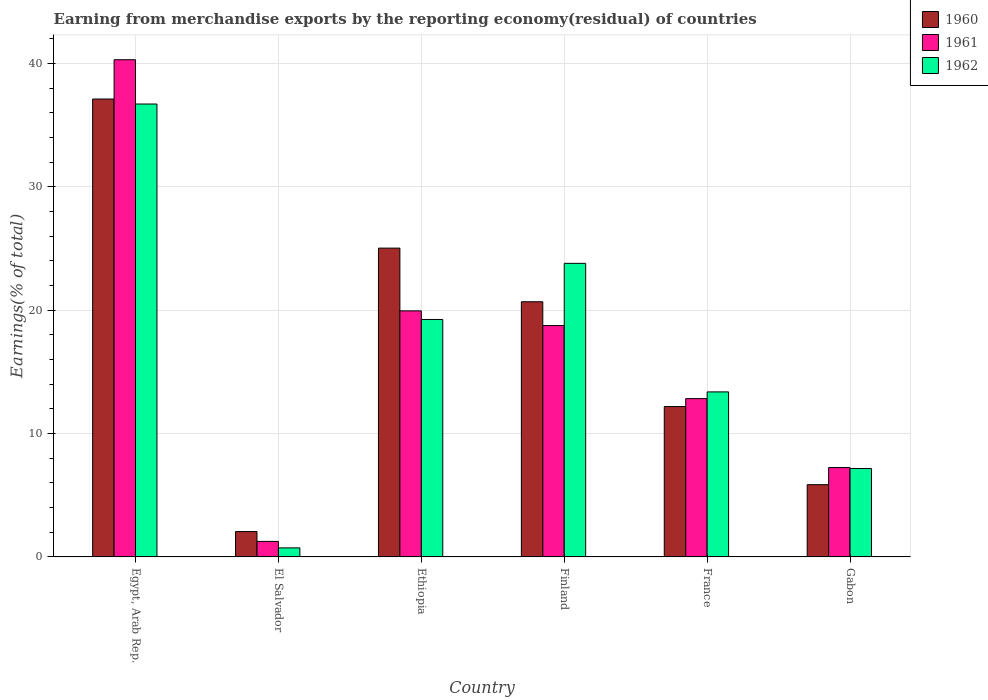How many different coloured bars are there?
Provide a short and direct response. 3. How many groups of bars are there?
Offer a terse response. 6. Are the number of bars per tick equal to the number of legend labels?
Provide a succinct answer. Yes. How many bars are there on the 5th tick from the left?
Provide a succinct answer. 3. How many bars are there on the 5th tick from the right?
Provide a short and direct response. 3. What is the label of the 3rd group of bars from the left?
Provide a succinct answer. Ethiopia. In how many cases, is the number of bars for a given country not equal to the number of legend labels?
Provide a succinct answer. 0. What is the percentage of amount earned from merchandise exports in 1960 in Ethiopia?
Provide a short and direct response. 25.03. Across all countries, what is the maximum percentage of amount earned from merchandise exports in 1960?
Your answer should be very brief. 37.12. Across all countries, what is the minimum percentage of amount earned from merchandise exports in 1962?
Your answer should be compact. 0.73. In which country was the percentage of amount earned from merchandise exports in 1962 maximum?
Give a very brief answer. Egypt, Arab Rep. In which country was the percentage of amount earned from merchandise exports in 1960 minimum?
Provide a short and direct response. El Salvador. What is the total percentage of amount earned from merchandise exports in 1962 in the graph?
Provide a short and direct response. 101.05. What is the difference between the percentage of amount earned from merchandise exports in 1960 in Egypt, Arab Rep. and that in France?
Offer a very short reply. 24.93. What is the difference between the percentage of amount earned from merchandise exports in 1961 in France and the percentage of amount earned from merchandise exports in 1960 in Ethiopia?
Make the answer very short. -12.2. What is the average percentage of amount earned from merchandise exports in 1962 per country?
Make the answer very short. 16.84. What is the difference between the percentage of amount earned from merchandise exports of/in 1961 and percentage of amount earned from merchandise exports of/in 1962 in Egypt, Arab Rep.?
Provide a succinct answer. 3.59. What is the ratio of the percentage of amount earned from merchandise exports in 1961 in Egypt, Arab Rep. to that in Finland?
Offer a very short reply. 2.15. Is the difference between the percentage of amount earned from merchandise exports in 1961 in Finland and Gabon greater than the difference between the percentage of amount earned from merchandise exports in 1962 in Finland and Gabon?
Your response must be concise. No. What is the difference between the highest and the second highest percentage of amount earned from merchandise exports in 1961?
Offer a terse response. 21.55. What is the difference between the highest and the lowest percentage of amount earned from merchandise exports in 1960?
Keep it short and to the point. 35.06. In how many countries, is the percentage of amount earned from merchandise exports in 1961 greater than the average percentage of amount earned from merchandise exports in 1961 taken over all countries?
Give a very brief answer. 3. What does the 2nd bar from the left in Ethiopia represents?
Make the answer very short. 1961. What does the 3rd bar from the right in Finland represents?
Make the answer very short. 1960. How many bars are there?
Your answer should be compact. 18. Does the graph contain any zero values?
Offer a very short reply. No. Does the graph contain grids?
Offer a very short reply. Yes. How are the legend labels stacked?
Your answer should be very brief. Vertical. What is the title of the graph?
Provide a succinct answer. Earning from merchandise exports by the reporting economy(residual) of countries. What is the label or title of the X-axis?
Offer a very short reply. Country. What is the label or title of the Y-axis?
Make the answer very short. Earnings(% of total). What is the Earnings(% of total) in 1960 in Egypt, Arab Rep.?
Offer a very short reply. 37.12. What is the Earnings(% of total) of 1961 in Egypt, Arab Rep.?
Your answer should be very brief. 40.31. What is the Earnings(% of total) of 1962 in Egypt, Arab Rep.?
Provide a short and direct response. 36.71. What is the Earnings(% of total) of 1960 in El Salvador?
Ensure brevity in your answer.  2.06. What is the Earnings(% of total) in 1961 in El Salvador?
Offer a terse response. 1.26. What is the Earnings(% of total) of 1962 in El Salvador?
Ensure brevity in your answer.  0.73. What is the Earnings(% of total) of 1960 in Ethiopia?
Ensure brevity in your answer.  25.03. What is the Earnings(% of total) of 1961 in Ethiopia?
Offer a very short reply. 19.95. What is the Earnings(% of total) in 1962 in Ethiopia?
Provide a succinct answer. 19.25. What is the Earnings(% of total) in 1960 in Finland?
Offer a very short reply. 20.69. What is the Earnings(% of total) of 1961 in Finland?
Offer a terse response. 18.76. What is the Earnings(% of total) of 1962 in Finland?
Make the answer very short. 23.8. What is the Earnings(% of total) of 1960 in France?
Your answer should be compact. 12.19. What is the Earnings(% of total) in 1961 in France?
Provide a short and direct response. 12.83. What is the Earnings(% of total) of 1962 in France?
Keep it short and to the point. 13.38. What is the Earnings(% of total) of 1960 in Gabon?
Your response must be concise. 5.86. What is the Earnings(% of total) of 1961 in Gabon?
Give a very brief answer. 7.25. What is the Earnings(% of total) in 1962 in Gabon?
Make the answer very short. 7.17. Across all countries, what is the maximum Earnings(% of total) of 1960?
Give a very brief answer. 37.12. Across all countries, what is the maximum Earnings(% of total) of 1961?
Provide a succinct answer. 40.31. Across all countries, what is the maximum Earnings(% of total) of 1962?
Offer a terse response. 36.71. Across all countries, what is the minimum Earnings(% of total) of 1960?
Keep it short and to the point. 2.06. Across all countries, what is the minimum Earnings(% of total) of 1961?
Your answer should be compact. 1.26. Across all countries, what is the minimum Earnings(% of total) of 1962?
Your response must be concise. 0.73. What is the total Earnings(% of total) in 1960 in the graph?
Offer a terse response. 102.94. What is the total Earnings(% of total) of 1961 in the graph?
Your answer should be compact. 100.35. What is the total Earnings(% of total) of 1962 in the graph?
Provide a succinct answer. 101.05. What is the difference between the Earnings(% of total) of 1960 in Egypt, Arab Rep. and that in El Salvador?
Your answer should be compact. 35.06. What is the difference between the Earnings(% of total) of 1961 in Egypt, Arab Rep. and that in El Salvador?
Keep it short and to the point. 39.05. What is the difference between the Earnings(% of total) in 1962 in Egypt, Arab Rep. and that in El Salvador?
Offer a very short reply. 35.98. What is the difference between the Earnings(% of total) in 1960 in Egypt, Arab Rep. and that in Ethiopia?
Your response must be concise. 12.09. What is the difference between the Earnings(% of total) of 1961 in Egypt, Arab Rep. and that in Ethiopia?
Keep it short and to the point. 20.36. What is the difference between the Earnings(% of total) in 1962 in Egypt, Arab Rep. and that in Ethiopia?
Your answer should be compact. 17.46. What is the difference between the Earnings(% of total) in 1960 in Egypt, Arab Rep. and that in Finland?
Your response must be concise. 16.43. What is the difference between the Earnings(% of total) in 1961 in Egypt, Arab Rep. and that in Finland?
Your answer should be very brief. 21.55. What is the difference between the Earnings(% of total) in 1962 in Egypt, Arab Rep. and that in Finland?
Offer a terse response. 12.91. What is the difference between the Earnings(% of total) in 1960 in Egypt, Arab Rep. and that in France?
Your response must be concise. 24.93. What is the difference between the Earnings(% of total) in 1961 in Egypt, Arab Rep. and that in France?
Provide a short and direct response. 27.47. What is the difference between the Earnings(% of total) in 1962 in Egypt, Arab Rep. and that in France?
Give a very brief answer. 23.34. What is the difference between the Earnings(% of total) in 1960 in Egypt, Arab Rep. and that in Gabon?
Your answer should be compact. 31.26. What is the difference between the Earnings(% of total) in 1961 in Egypt, Arab Rep. and that in Gabon?
Keep it short and to the point. 33.06. What is the difference between the Earnings(% of total) in 1962 in Egypt, Arab Rep. and that in Gabon?
Provide a short and direct response. 29.55. What is the difference between the Earnings(% of total) of 1960 in El Salvador and that in Ethiopia?
Offer a terse response. -22.98. What is the difference between the Earnings(% of total) in 1961 in El Salvador and that in Ethiopia?
Provide a short and direct response. -18.69. What is the difference between the Earnings(% of total) of 1962 in El Salvador and that in Ethiopia?
Ensure brevity in your answer.  -18.52. What is the difference between the Earnings(% of total) in 1960 in El Salvador and that in Finland?
Offer a terse response. -18.63. What is the difference between the Earnings(% of total) of 1961 in El Salvador and that in Finland?
Give a very brief answer. -17.5. What is the difference between the Earnings(% of total) of 1962 in El Salvador and that in Finland?
Your answer should be compact. -23.07. What is the difference between the Earnings(% of total) in 1960 in El Salvador and that in France?
Keep it short and to the point. -10.13. What is the difference between the Earnings(% of total) of 1961 in El Salvador and that in France?
Provide a succinct answer. -11.58. What is the difference between the Earnings(% of total) in 1962 in El Salvador and that in France?
Ensure brevity in your answer.  -12.65. What is the difference between the Earnings(% of total) of 1960 in El Salvador and that in Gabon?
Provide a short and direct response. -3.8. What is the difference between the Earnings(% of total) of 1961 in El Salvador and that in Gabon?
Make the answer very short. -5.99. What is the difference between the Earnings(% of total) of 1962 in El Salvador and that in Gabon?
Offer a terse response. -6.43. What is the difference between the Earnings(% of total) in 1960 in Ethiopia and that in Finland?
Give a very brief answer. 4.35. What is the difference between the Earnings(% of total) in 1961 in Ethiopia and that in Finland?
Your response must be concise. 1.19. What is the difference between the Earnings(% of total) of 1962 in Ethiopia and that in Finland?
Offer a terse response. -4.55. What is the difference between the Earnings(% of total) in 1960 in Ethiopia and that in France?
Your answer should be very brief. 12.84. What is the difference between the Earnings(% of total) of 1961 in Ethiopia and that in France?
Make the answer very short. 7.11. What is the difference between the Earnings(% of total) in 1962 in Ethiopia and that in France?
Your answer should be very brief. 5.87. What is the difference between the Earnings(% of total) of 1960 in Ethiopia and that in Gabon?
Offer a very short reply. 19.18. What is the difference between the Earnings(% of total) in 1961 in Ethiopia and that in Gabon?
Ensure brevity in your answer.  12.7. What is the difference between the Earnings(% of total) of 1962 in Ethiopia and that in Gabon?
Your response must be concise. 12.08. What is the difference between the Earnings(% of total) in 1960 in Finland and that in France?
Provide a succinct answer. 8.5. What is the difference between the Earnings(% of total) in 1961 in Finland and that in France?
Offer a terse response. 5.92. What is the difference between the Earnings(% of total) in 1962 in Finland and that in France?
Provide a succinct answer. 10.42. What is the difference between the Earnings(% of total) of 1960 in Finland and that in Gabon?
Your answer should be very brief. 14.83. What is the difference between the Earnings(% of total) of 1961 in Finland and that in Gabon?
Make the answer very short. 11.51. What is the difference between the Earnings(% of total) in 1962 in Finland and that in Gabon?
Give a very brief answer. 16.63. What is the difference between the Earnings(% of total) of 1960 in France and that in Gabon?
Your response must be concise. 6.33. What is the difference between the Earnings(% of total) in 1961 in France and that in Gabon?
Offer a terse response. 5.59. What is the difference between the Earnings(% of total) in 1962 in France and that in Gabon?
Your response must be concise. 6.21. What is the difference between the Earnings(% of total) of 1960 in Egypt, Arab Rep. and the Earnings(% of total) of 1961 in El Salvador?
Ensure brevity in your answer.  35.86. What is the difference between the Earnings(% of total) in 1960 in Egypt, Arab Rep. and the Earnings(% of total) in 1962 in El Salvador?
Offer a terse response. 36.39. What is the difference between the Earnings(% of total) of 1961 in Egypt, Arab Rep. and the Earnings(% of total) of 1962 in El Salvador?
Offer a terse response. 39.57. What is the difference between the Earnings(% of total) in 1960 in Egypt, Arab Rep. and the Earnings(% of total) in 1961 in Ethiopia?
Provide a succinct answer. 17.17. What is the difference between the Earnings(% of total) in 1960 in Egypt, Arab Rep. and the Earnings(% of total) in 1962 in Ethiopia?
Ensure brevity in your answer.  17.87. What is the difference between the Earnings(% of total) in 1961 in Egypt, Arab Rep. and the Earnings(% of total) in 1962 in Ethiopia?
Offer a terse response. 21.06. What is the difference between the Earnings(% of total) in 1960 in Egypt, Arab Rep. and the Earnings(% of total) in 1961 in Finland?
Your answer should be compact. 18.36. What is the difference between the Earnings(% of total) in 1960 in Egypt, Arab Rep. and the Earnings(% of total) in 1962 in Finland?
Make the answer very short. 13.32. What is the difference between the Earnings(% of total) of 1961 in Egypt, Arab Rep. and the Earnings(% of total) of 1962 in Finland?
Give a very brief answer. 16.5. What is the difference between the Earnings(% of total) of 1960 in Egypt, Arab Rep. and the Earnings(% of total) of 1961 in France?
Offer a very short reply. 24.29. What is the difference between the Earnings(% of total) of 1960 in Egypt, Arab Rep. and the Earnings(% of total) of 1962 in France?
Offer a terse response. 23.74. What is the difference between the Earnings(% of total) of 1961 in Egypt, Arab Rep. and the Earnings(% of total) of 1962 in France?
Give a very brief answer. 26.93. What is the difference between the Earnings(% of total) of 1960 in Egypt, Arab Rep. and the Earnings(% of total) of 1961 in Gabon?
Provide a short and direct response. 29.87. What is the difference between the Earnings(% of total) in 1960 in Egypt, Arab Rep. and the Earnings(% of total) in 1962 in Gabon?
Provide a succinct answer. 29.95. What is the difference between the Earnings(% of total) of 1961 in Egypt, Arab Rep. and the Earnings(% of total) of 1962 in Gabon?
Provide a short and direct response. 33.14. What is the difference between the Earnings(% of total) of 1960 in El Salvador and the Earnings(% of total) of 1961 in Ethiopia?
Your answer should be very brief. -17.89. What is the difference between the Earnings(% of total) in 1960 in El Salvador and the Earnings(% of total) in 1962 in Ethiopia?
Your response must be concise. -17.19. What is the difference between the Earnings(% of total) in 1961 in El Salvador and the Earnings(% of total) in 1962 in Ethiopia?
Your answer should be compact. -17.99. What is the difference between the Earnings(% of total) in 1960 in El Salvador and the Earnings(% of total) in 1961 in Finland?
Offer a terse response. -16.7. What is the difference between the Earnings(% of total) in 1960 in El Salvador and the Earnings(% of total) in 1962 in Finland?
Offer a very short reply. -21.74. What is the difference between the Earnings(% of total) in 1961 in El Salvador and the Earnings(% of total) in 1962 in Finland?
Keep it short and to the point. -22.54. What is the difference between the Earnings(% of total) of 1960 in El Salvador and the Earnings(% of total) of 1961 in France?
Your answer should be compact. -10.78. What is the difference between the Earnings(% of total) in 1960 in El Salvador and the Earnings(% of total) in 1962 in France?
Give a very brief answer. -11.32. What is the difference between the Earnings(% of total) of 1961 in El Salvador and the Earnings(% of total) of 1962 in France?
Offer a very short reply. -12.12. What is the difference between the Earnings(% of total) in 1960 in El Salvador and the Earnings(% of total) in 1961 in Gabon?
Your answer should be very brief. -5.19. What is the difference between the Earnings(% of total) of 1960 in El Salvador and the Earnings(% of total) of 1962 in Gabon?
Offer a very short reply. -5.11. What is the difference between the Earnings(% of total) in 1961 in El Salvador and the Earnings(% of total) in 1962 in Gabon?
Keep it short and to the point. -5.91. What is the difference between the Earnings(% of total) in 1960 in Ethiopia and the Earnings(% of total) in 1961 in Finland?
Your answer should be compact. 6.28. What is the difference between the Earnings(% of total) in 1960 in Ethiopia and the Earnings(% of total) in 1962 in Finland?
Provide a succinct answer. 1.23. What is the difference between the Earnings(% of total) in 1961 in Ethiopia and the Earnings(% of total) in 1962 in Finland?
Offer a terse response. -3.85. What is the difference between the Earnings(% of total) in 1960 in Ethiopia and the Earnings(% of total) in 1961 in France?
Give a very brief answer. 12.2. What is the difference between the Earnings(% of total) of 1960 in Ethiopia and the Earnings(% of total) of 1962 in France?
Offer a very short reply. 11.65. What is the difference between the Earnings(% of total) in 1961 in Ethiopia and the Earnings(% of total) in 1962 in France?
Provide a short and direct response. 6.57. What is the difference between the Earnings(% of total) of 1960 in Ethiopia and the Earnings(% of total) of 1961 in Gabon?
Give a very brief answer. 17.79. What is the difference between the Earnings(% of total) in 1960 in Ethiopia and the Earnings(% of total) in 1962 in Gabon?
Give a very brief answer. 17.87. What is the difference between the Earnings(% of total) in 1961 in Ethiopia and the Earnings(% of total) in 1962 in Gabon?
Your answer should be compact. 12.78. What is the difference between the Earnings(% of total) of 1960 in Finland and the Earnings(% of total) of 1961 in France?
Offer a terse response. 7.85. What is the difference between the Earnings(% of total) of 1960 in Finland and the Earnings(% of total) of 1962 in France?
Your response must be concise. 7.31. What is the difference between the Earnings(% of total) in 1961 in Finland and the Earnings(% of total) in 1962 in France?
Offer a terse response. 5.38. What is the difference between the Earnings(% of total) of 1960 in Finland and the Earnings(% of total) of 1961 in Gabon?
Your answer should be compact. 13.44. What is the difference between the Earnings(% of total) of 1960 in Finland and the Earnings(% of total) of 1962 in Gabon?
Offer a very short reply. 13.52. What is the difference between the Earnings(% of total) of 1961 in Finland and the Earnings(% of total) of 1962 in Gabon?
Your response must be concise. 11.59. What is the difference between the Earnings(% of total) of 1960 in France and the Earnings(% of total) of 1961 in Gabon?
Your response must be concise. 4.94. What is the difference between the Earnings(% of total) in 1960 in France and the Earnings(% of total) in 1962 in Gabon?
Keep it short and to the point. 5.02. What is the difference between the Earnings(% of total) in 1961 in France and the Earnings(% of total) in 1962 in Gabon?
Give a very brief answer. 5.67. What is the average Earnings(% of total) in 1960 per country?
Offer a terse response. 17.16. What is the average Earnings(% of total) of 1961 per country?
Your answer should be very brief. 16.72. What is the average Earnings(% of total) in 1962 per country?
Give a very brief answer. 16.84. What is the difference between the Earnings(% of total) of 1960 and Earnings(% of total) of 1961 in Egypt, Arab Rep.?
Keep it short and to the point. -3.18. What is the difference between the Earnings(% of total) in 1960 and Earnings(% of total) in 1962 in Egypt, Arab Rep.?
Your response must be concise. 0.41. What is the difference between the Earnings(% of total) of 1961 and Earnings(% of total) of 1962 in Egypt, Arab Rep.?
Your response must be concise. 3.59. What is the difference between the Earnings(% of total) of 1960 and Earnings(% of total) of 1961 in El Salvador?
Provide a short and direct response. 0.8. What is the difference between the Earnings(% of total) of 1960 and Earnings(% of total) of 1962 in El Salvador?
Ensure brevity in your answer.  1.32. What is the difference between the Earnings(% of total) of 1961 and Earnings(% of total) of 1962 in El Salvador?
Offer a very short reply. 0.52. What is the difference between the Earnings(% of total) of 1960 and Earnings(% of total) of 1961 in Ethiopia?
Offer a very short reply. 5.09. What is the difference between the Earnings(% of total) in 1960 and Earnings(% of total) in 1962 in Ethiopia?
Provide a short and direct response. 5.78. What is the difference between the Earnings(% of total) in 1961 and Earnings(% of total) in 1962 in Ethiopia?
Offer a very short reply. 0.7. What is the difference between the Earnings(% of total) of 1960 and Earnings(% of total) of 1961 in Finland?
Offer a very short reply. 1.93. What is the difference between the Earnings(% of total) of 1960 and Earnings(% of total) of 1962 in Finland?
Your answer should be compact. -3.11. What is the difference between the Earnings(% of total) of 1961 and Earnings(% of total) of 1962 in Finland?
Offer a very short reply. -5.04. What is the difference between the Earnings(% of total) of 1960 and Earnings(% of total) of 1961 in France?
Keep it short and to the point. -0.64. What is the difference between the Earnings(% of total) of 1960 and Earnings(% of total) of 1962 in France?
Make the answer very short. -1.19. What is the difference between the Earnings(% of total) in 1961 and Earnings(% of total) in 1962 in France?
Offer a terse response. -0.55. What is the difference between the Earnings(% of total) in 1960 and Earnings(% of total) in 1961 in Gabon?
Your answer should be very brief. -1.39. What is the difference between the Earnings(% of total) of 1960 and Earnings(% of total) of 1962 in Gabon?
Your answer should be compact. -1.31. What is the difference between the Earnings(% of total) of 1961 and Earnings(% of total) of 1962 in Gabon?
Make the answer very short. 0.08. What is the ratio of the Earnings(% of total) of 1960 in Egypt, Arab Rep. to that in El Salvador?
Your answer should be very brief. 18.05. What is the ratio of the Earnings(% of total) of 1961 in Egypt, Arab Rep. to that in El Salvador?
Your answer should be compact. 32.03. What is the ratio of the Earnings(% of total) in 1962 in Egypt, Arab Rep. to that in El Salvador?
Make the answer very short. 50.04. What is the ratio of the Earnings(% of total) in 1960 in Egypt, Arab Rep. to that in Ethiopia?
Ensure brevity in your answer.  1.48. What is the ratio of the Earnings(% of total) of 1961 in Egypt, Arab Rep. to that in Ethiopia?
Offer a terse response. 2.02. What is the ratio of the Earnings(% of total) in 1962 in Egypt, Arab Rep. to that in Ethiopia?
Ensure brevity in your answer.  1.91. What is the ratio of the Earnings(% of total) of 1960 in Egypt, Arab Rep. to that in Finland?
Make the answer very short. 1.79. What is the ratio of the Earnings(% of total) of 1961 in Egypt, Arab Rep. to that in Finland?
Give a very brief answer. 2.15. What is the ratio of the Earnings(% of total) of 1962 in Egypt, Arab Rep. to that in Finland?
Your response must be concise. 1.54. What is the ratio of the Earnings(% of total) of 1960 in Egypt, Arab Rep. to that in France?
Your answer should be compact. 3.05. What is the ratio of the Earnings(% of total) in 1961 in Egypt, Arab Rep. to that in France?
Offer a terse response. 3.14. What is the ratio of the Earnings(% of total) in 1962 in Egypt, Arab Rep. to that in France?
Give a very brief answer. 2.74. What is the ratio of the Earnings(% of total) of 1960 in Egypt, Arab Rep. to that in Gabon?
Your answer should be very brief. 6.34. What is the ratio of the Earnings(% of total) in 1961 in Egypt, Arab Rep. to that in Gabon?
Provide a short and direct response. 5.56. What is the ratio of the Earnings(% of total) in 1962 in Egypt, Arab Rep. to that in Gabon?
Make the answer very short. 5.12. What is the ratio of the Earnings(% of total) in 1960 in El Salvador to that in Ethiopia?
Your answer should be compact. 0.08. What is the ratio of the Earnings(% of total) of 1961 in El Salvador to that in Ethiopia?
Keep it short and to the point. 0.06. What is the ratio of the Earnings(% of total) in 1962 in El Salvador to that in Ethiopia?
Ensure brevity in your answer.  0.04. What is the ratio of the Earnings(% of total) in 1960 in El Salvador to that in Finland?
Offer a terse response. 0.1. What is the ratio of the Earnings(% of total) in 1961 in El Salvador to that in Finland?
Give a very brief answer. 0.07. What is the ratio of the Earnings(% of total) in 1962 in El Salvador to that in Finland?
Give a very brief answer. 0.03. What is the ratio of the Earnings(% of total) of 1960 in El Salvador to that in France?
Your response must be concise. 0.17. What is the ratio of the Earnings(% of total) of 1961 in El Salvador to that in France?
Offer a terse response. 0.1. What is the ratio of the Earnings(% of total) in 1962 in El Salvador to that in France?
Your response must be concise. 0.05. What is the ratio of the Earnings(% of total) in 1960 in El Salvador to that in Gabon?
Ensure brevity in your answer.  0.35. What is the ratio of the Earnings(% of total) in 1961 in El Salvador to that in Gabon?
Offer a very short reply. 0.17. What is the ratio of the Earnings(% of total) of 1962 in El Salvador to that in Gabon?
Your answer should be compact. 0.1. What is the ratio of the Earnings(% of total) in 1960 in Ethiopia to that in Finland?
Provide a succinct answer. 1.21. What is the ratio of the Earnings(% of total) in 1961 in Ethiopia to that in Finland?
Your answer should be very brief. 1.06. What is the ratio of the Earnings(% of total) in 1962 in Ethiopia to that in Finland?
Give a very brief answer. 0.81. What is the ratio of the Earnings(% of total) in 1960 in Ethiopia to that in France?
Your response must be concise. 2.05. What is the ratio of the Earnings(% of total) of 1961 in Ethiopia to that in France?
Keep it short and to the point. 1.55. What is the ratio of the Earnings(% of total) in 1962 in Ethiopia to that in France?
Offer a very short reply. 1.44. What is the ratio of the Earnings(% of total) in 1960 in Ethiopia to that in Gabon?
Offer a terse response. 4.27. What is the ratio of the Earnings(% of total) in 1961 in Ethiopia to that in Gabon?
Give a very brief answer. 2.75. What is the ratio of the Earnings(% of total) in 1962 in Ethiopia to that in Gabon?
Offer a very short reply. 2.69. What is the ratio of the Earnings(% of total) of 1960 in Finland to that in France?
Ensure brevity in your answer.  1.7. What is the ratio of the Earnings(% of total) of 1961 in Finland to that in France?
Your response must be concise. 1.46. What is the ratio of the Earnings(% of total) of 1962 in Finland to that in France?
Make the answer very short. 1.78. What is the ratio of the Earnings(% of total) in 1960 in Finland to that in Gabon?
Keep it short and to the point. 3.53. What is the ratio of the Earnings(% of total) in 1961 in Finland to that in Gabon?
Make the answer very short. 2.59. What is the ratio of the Earnings(% of total) of 1962 in Finland to that in Gabon?
Provide a short and direct response. 3.32. What is the ratio of the Earnings(% of total) of 1960 in France to that in Gabon?
Your answer should be compact. 2.08. What is the ratio of the Earnings(% of total) of 1961 in France to that in Gabon?
Give a very brief answer. 1.77. What is the ratio of the Earnings(% of total) in 1962 in France to that in Gabon?
Ensure brevity in your answer.  1.87. What is the difference between the highest and the second highest Earnings(% of total) of 1960?
Your answer should be compact. 12.09. What is the difference between the highest and the second highest Earnings(% of total) in 1961?
Give a very brief answer. 20.36. What is the difference between the highest and the second highest Earnings(% of total) of 1962?
Ensure brevity in your answer.  12.91. What is the difference between the highest and the lowest Earnings(% of total) in 1960?
Provide a short and direct response. 35.06. What is the difference between the highest and the lowest Earnings(% of total) of 1961?
Provide a short and direct response. 39.05. What is the difference between the highest and the lowest Earnings(% of total) in 1962?
Keep it short and to the point. 35.98. 